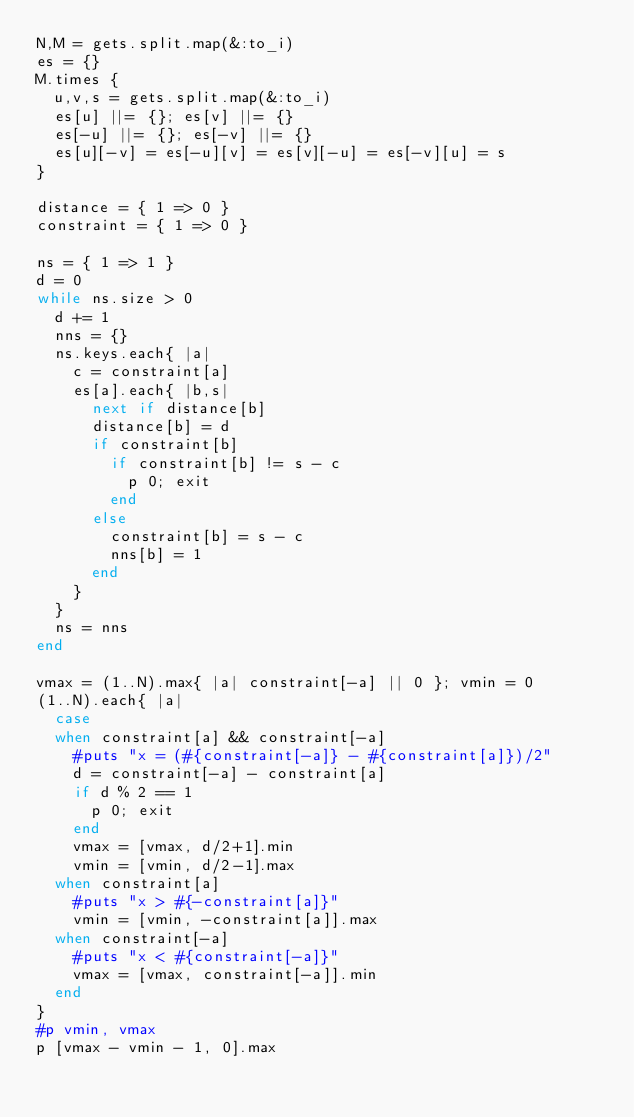Convert code to text. <code><loc_0><loc_0><loc_500><loc_500><_Ruby_>N,M = gets.split.map(&:to_i)
es = {}
M.times {
  u,v,s = gets.split.map(&:to_i)
  es[u] ||= {}; es[v] ||= {}
  es[-u] ||= {}; es[-v] ||= {}
  es[u][-v] = es[-u][v] = es[v][-u] = es[-v][u] = s
}

distance = { 1 => 0 }
constraint = { 1 => 0 }

ns = { 1 => 1 }
d = 0
while ns.size > 0
  d += 1
  nns = {}
  ns.keys.each{ |a|
    c = constraint[a]
    es[a].each{ |b,s|
      next if distance[b]
      distance[b] = d
      if constraint[b]
        if constraint[b] != s - c
          p 0; exit
        end
      else
        constraint[b] = s - c
        nns[b] = 1
      end
    }
  }
  ns = nns
end

vmax = (1..N).max{ |a| constraint[-a] || 0 }; vmin = 0
(1..N).each{ |a|
  case
  when constraint[a] && constraint[-a]
    #puts "x = (#{constraint[-a]} - #{constraint[a]})/2"
    d = constraint[-a] - constraint[a]
    if d % 2 == 1
      p 0; exit
    end
    vmax = [vmax, d/2+1].min
    vmin = [vmin, d/2-1].max
  when constraint[a]
    #puts "x > #{-constraint[a]}"
    vmin = [vmin, -constraint[a]].max
  when constraint[-a]
    #puts "x < #{constraint[-a]}"
    vmax = [vmax, constraint[-a]].min
  end
}
#p vmin, vmax
p [vmax - vmin - 1, 0].max
</code> 